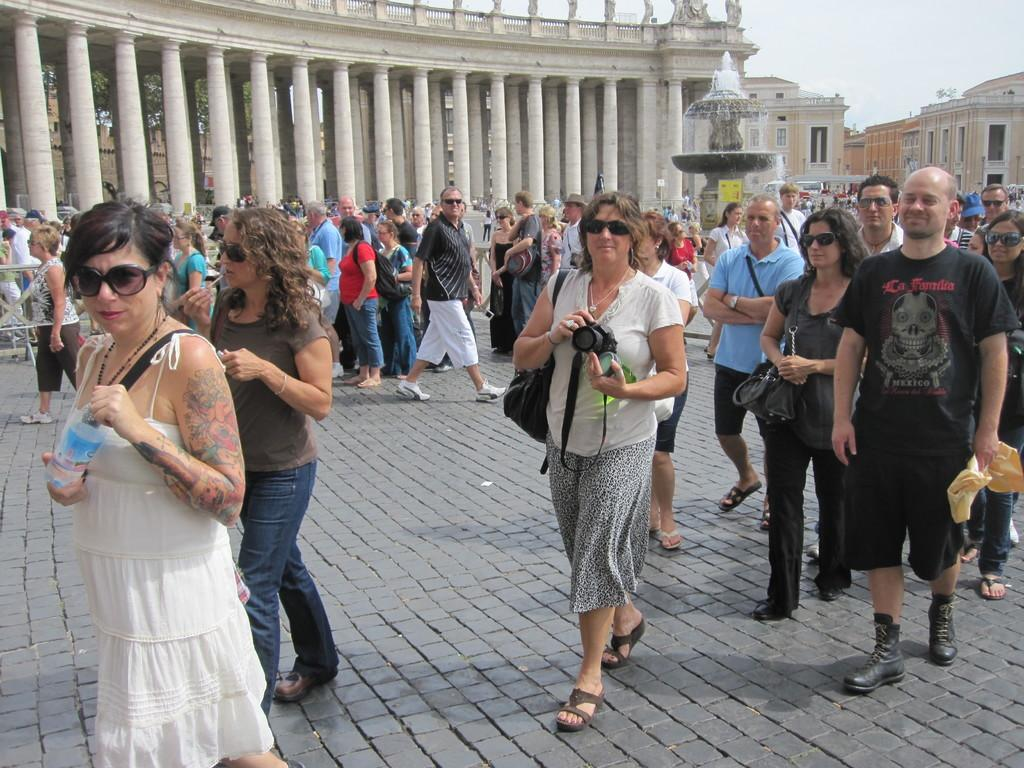What are the people in the image doing? The people in the image are standing and walking on the road. What is a prominent feature in the image? There is a fountain in the image. What can be seen in the distance in the image? There are buildings in the background of the image. What is visible in the sky in the image? The sky is visible in the background of the image. What type of zipper can be seen on the page in the image? There is no zipper or page present in the image. What kind of party is happening in the background of the image? There is no party visible in the image; it features people on a road, a fountain, buildings, and the sky. 